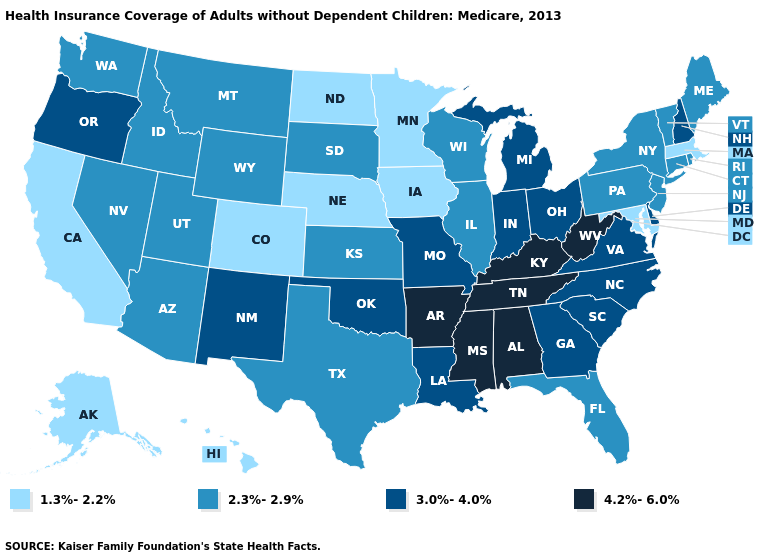What is the highest value in the USA?
Answer briefly. 4.2%-6.0%. Does New Mexico have the highest value in the West?
Short answer required. Yes. Does Georgia have the lowest value in the USA?
Be succinct. No. Does Connecticut have the lowest value in the USA?
Concise answer only. No. What is the value of New Hampshire?
Be succinct. 3.0%-4.0%. Does the map have missing data?
Quick response, please. No. Which states have the lowest value in the USA?
Short answer required. Alaska, California, Colorado, Hawaii, Iowa, Maryland, Massachusetts, Minnesota, Nebraska, North Dakota. How many symbols are there in the legend?
Give a very brief answer. 4. What is the lowest value in the USA?
Short answer required. 1.3%-2.2%. Among the states that border Indiana , does Kentucky have the highest value?
Quick response, please. Yes. Does Pennsylvania have the lowest value in the Northeast?
Write a very short answer. No. What is the value of New Jersey?
Write a very short answer. 2.3%-2.9%. What is the value of North Carolina?
Be succinct. 3.0%-4.0%. Name the states that have a value in the range 1.3%-2.2%?
Concise answer only. Alaska, California, Colorado, Hawaii, Iowa, Maryland, Massachusetts, Minnesota, Nebraska, North Dakota. 